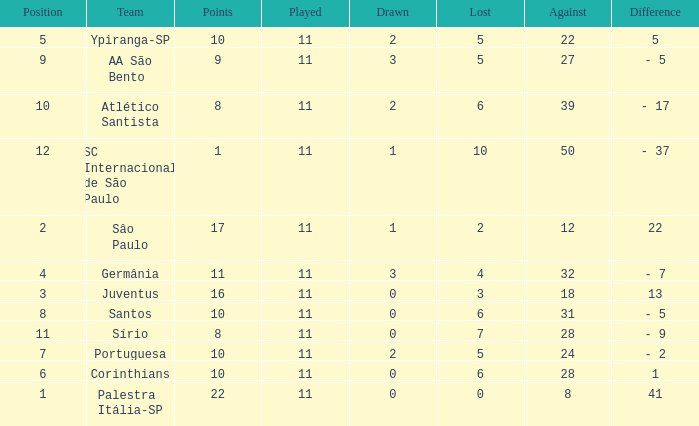Could you parse the entire table as a dict? {'header': ['Position', 'Team', 'Points', 'Played', 'Drawn', 'Lost', 'Against', 'Difference'], 'rows': [['5', 'Ypiranga-SP', '10', '11', '2', '5', '22', '5'], ['9', 'AA São Bento', '9', '11', '3', '5', '27', '- 5'], ['10', 'Atlético Santista', '8', '11', '2', '6', '39', '- 17'], ['12', 'SC Internacional de São Paulo', '1', '11', '1', '10', '50', '- 37'], ['2', 'Sâo Paulo', '17', '11', '1', '2', '12', '22'], ['4', 'Germânia', '11', '11', '3', '4', '32', '- 7'], ['3', 'Juventus', '16', '11', '0', '3', '18', '13'], ['8', 'Santos', '10', '11', '0', '6', '31', '- 5'], ['11', 'Sírio', '8', '11', '0', '7', '28', '- 9'], ['7', 'Portuguesa', '10', '11', '2', '5', '24', '- 2'], ['6', 'Corinthians', '10', '11', '0', '6', '28', '1'], ['1', 'Palestra Itália-SP', '22', '11', '0', '0', '8', '41']]} What was the total number of Points when the value Difference was 13, and when the value Lost was greater than 3? None. 